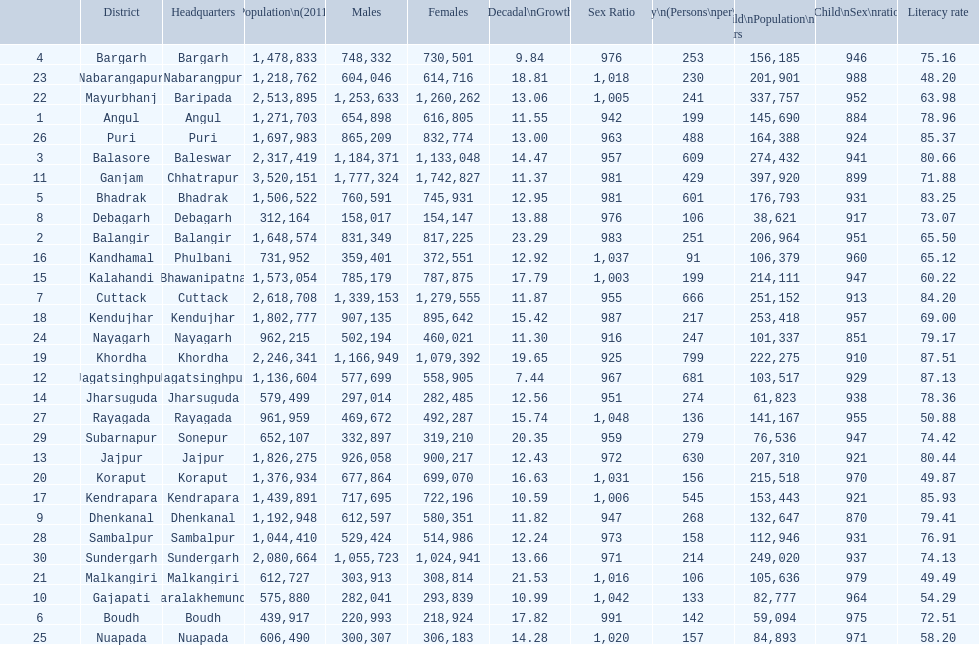In which district was the population growth the lowest between 2001 and 2011? Jagatsinghpur. 